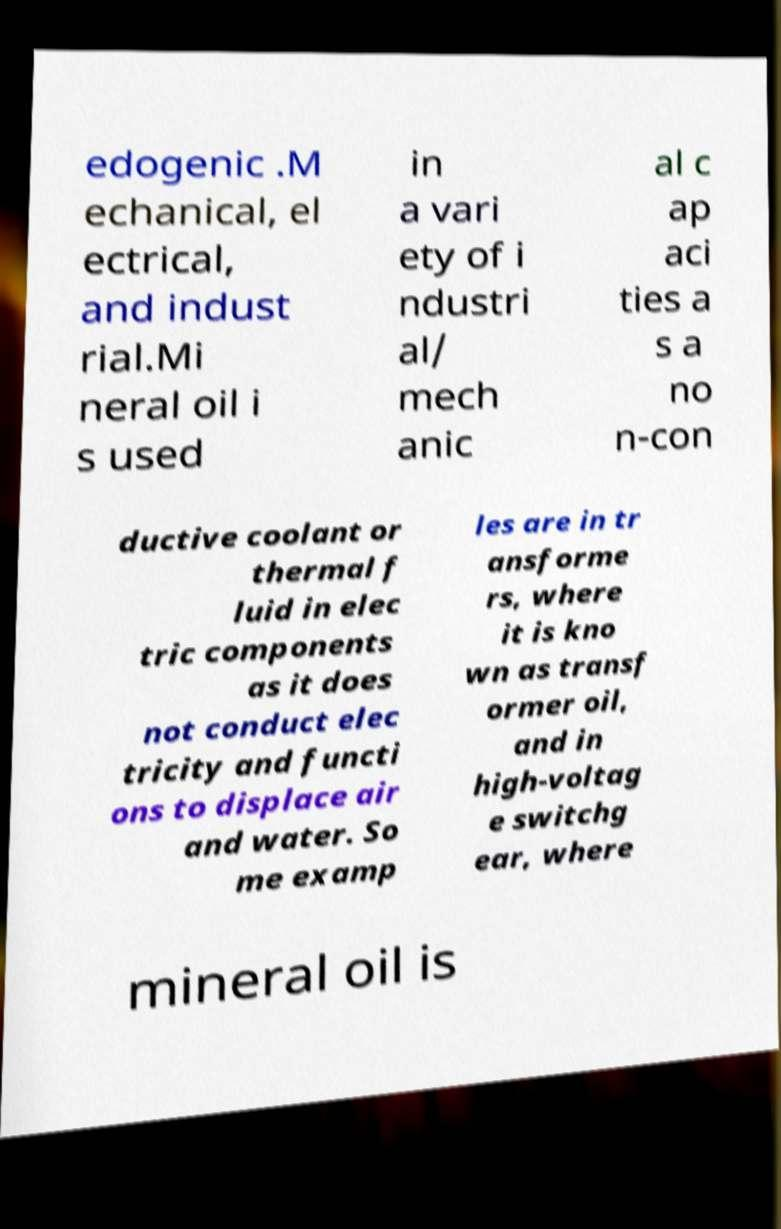Could you extract and type out the text from this image? edogenic .M echanical, el ectrical, and indust rial.Mi neral oil i s used in a vari ety of i ndustri al/ mech anic al c ap aci ties a s a no n-con ductive coolant or thermal f luid in elec tric components as it does not conduct elec tricity and functi ons to displace air and water. So me examp les are in tr ansforme rs, where it is kno wn as transf ormer oil, and in high-voltag e switchg ear, where mineral oil is 